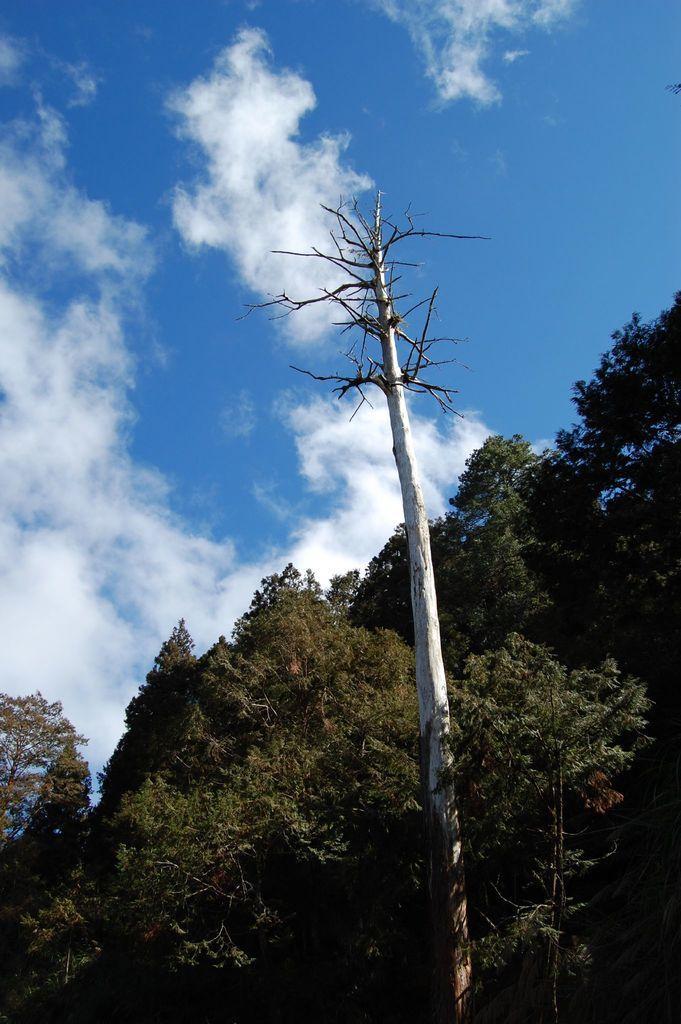Please provide a concise description of this image. In this picture there are few trees and the sky is a bit cloudy. 